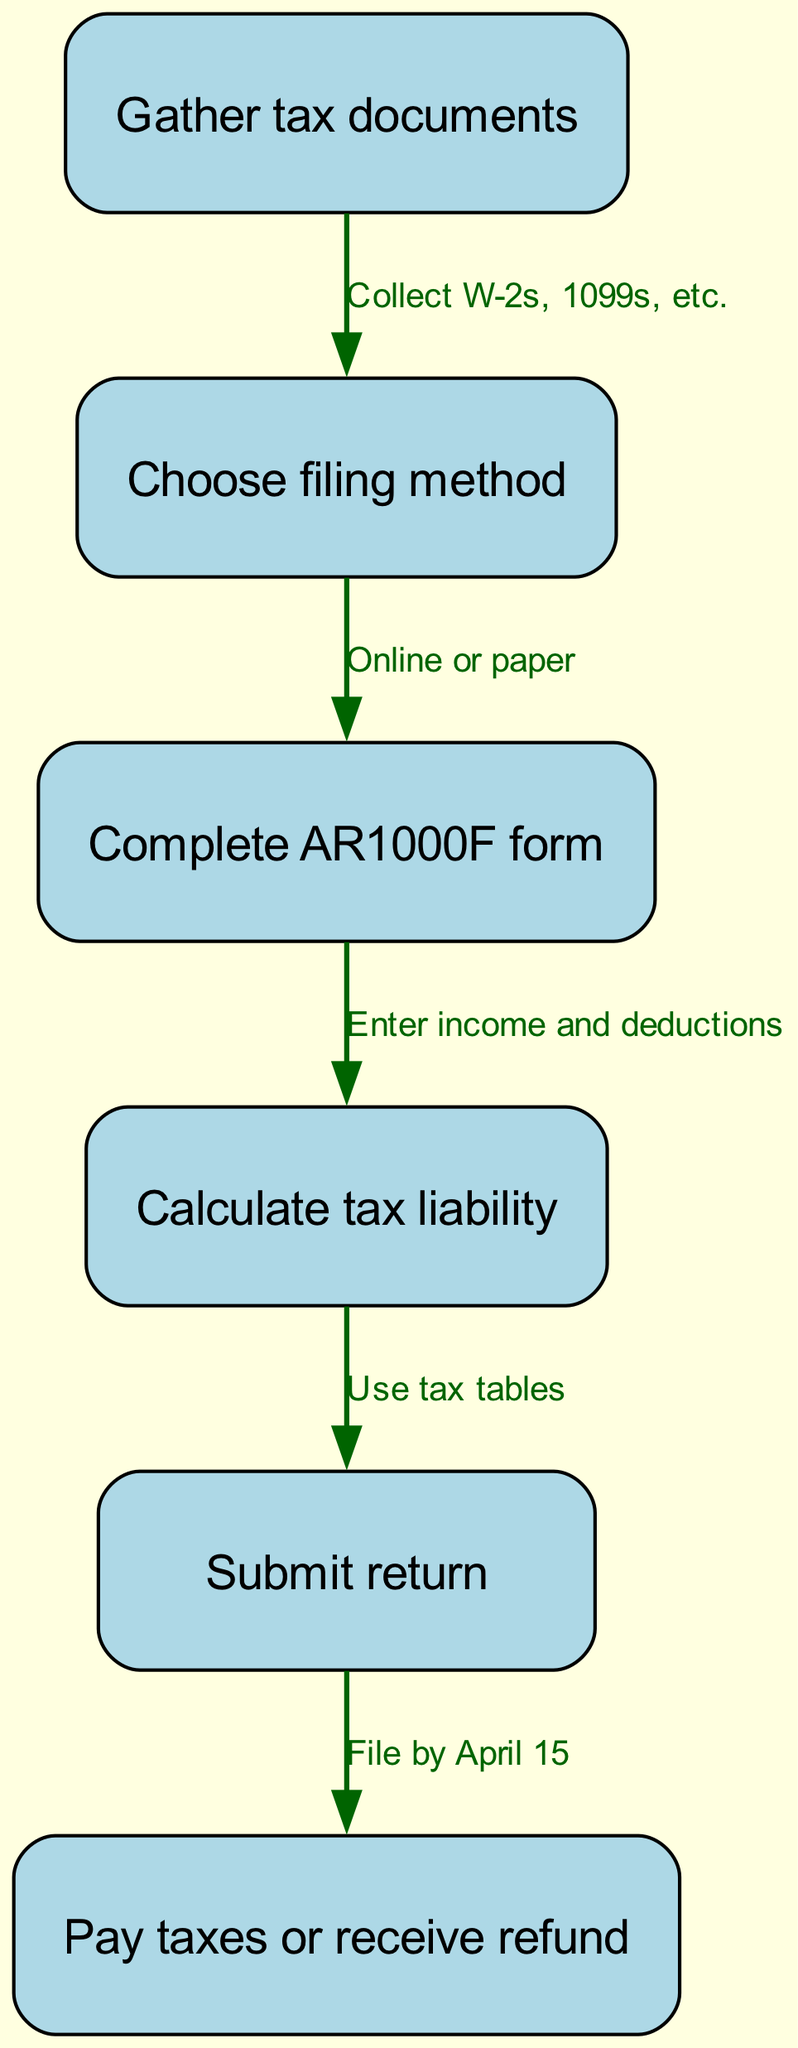What is the first step in the tax return process? The diagram shows that the first step is to "Gather tax documents." This is identified as the initial node (1) in the flow of the diagram.
Answer: Gather tax documents How many nodes are in the diagram? By counting the distinct steps listed in the diagram, we see there are six nodes representing different actions in the tax return process.
Answer: 6 What is the last step in the tax return process? The final step is labeled "Pay taxes or receive refund." This can be found as node (6) positioned at the end of the sequence.
Answer: Pay taxes or receive refund What is the relationship between node 2 and node 3? Node 2 indicates "Choose filing method," and node 3 indicates "Complete AR1000F form." According to the directed edge from node 2 to node 3, the relationship is that one must choose the filing method before completing the form.
Answer: Online or paper What is needed before calculating tax liability? Before calculating tax liability, one must "Complete AR1000F form," as shown in the directed flow from node 3 to node 4. This step involves entering income and deductions that are necessary for the calculation.
Answer: Complete AR1000F form What must be filed by April 15? The diagram specifies that the action "Submit return" must be completed by April 15, indicated by the directed edge leading to node 6.
Answer: Submit return Which step involves entering income and deductions? The process described in the diagram includes entering income and deductions as part of "Complete AR1000F form," which is shown as node 3 connected to node 4.
Answer: Complete AR1000F form How do you submit your state tax return? According to the diagram, the state tax return is submitted as indicated in step 5, which is connected from "Calculate tax liability" in step 4 to "Pay taxes or receive refund" in step 6.
Answer: Submit return What is the document used to file taxes in Arkansas? The necessary document for filing taxes in Arkansas is referred to as the "AR1000F form." This is stated clearly in node 3 of the diagram.
Answer: AR1000F form 